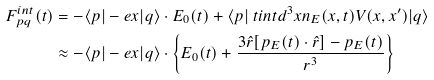Convert formula to latex. <formula><loc_0><loc_0><loc_500><loc_500>F ^ { i n t } _ { p q } ( t ) & = - \langle p | - e { x } | q \rangle \cdot { E } _ { 0 } ( t ) + \langle p | { \ t i n t } d ^ { 3 } x n _ { E } ( { x } , t ) V ( { x } , { x } ^ { \prime } ) | q \rangle \\ & \approx - \langle p | - e { x } | q \rangle \cdot \left \{ { E } _ { 0 } ( t ) + \frac { 3 \hat { r } [ { p } _ { E } ( t ) \cdot \hat { r } ] - { p } _ { E } ( t ) } { r ^ { 3 } } \right \}</formula> 